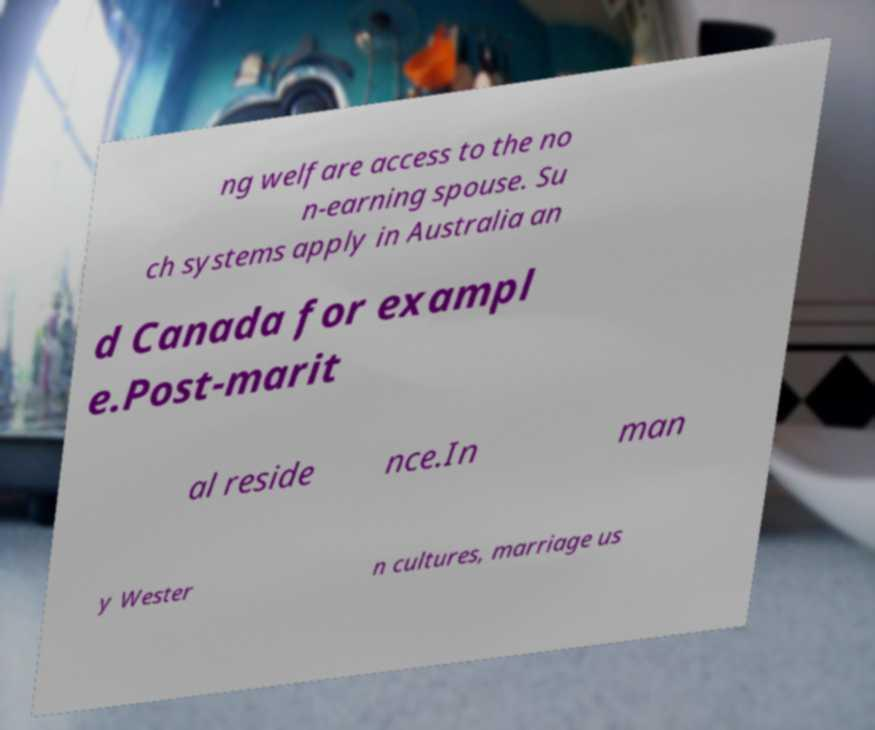What messages or text are displayed in this image? I need them in a readable, typed format. ng welfare access to the no n-earning spouse. Su ch systems apply in Australia an d Canada for exampl e.Post-marit al reside nce.In man y Wester n cultures, marriage us 